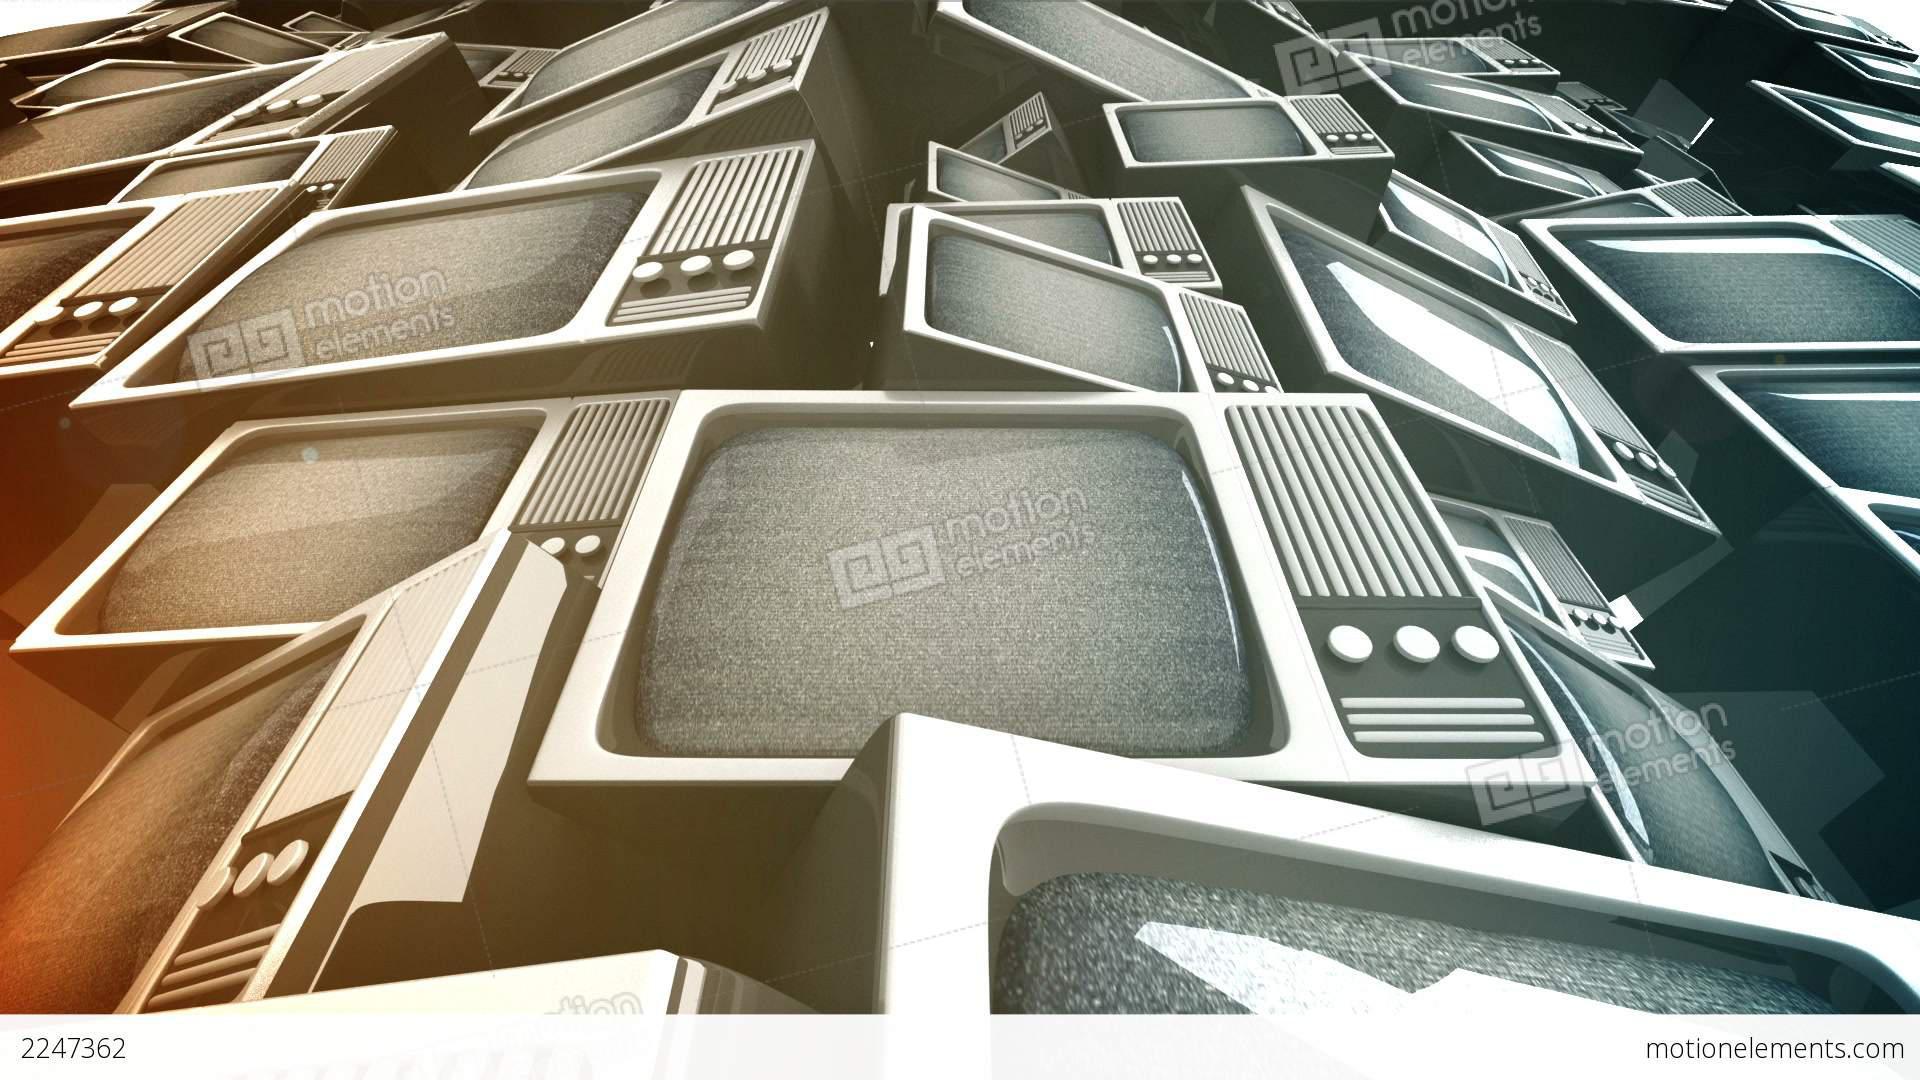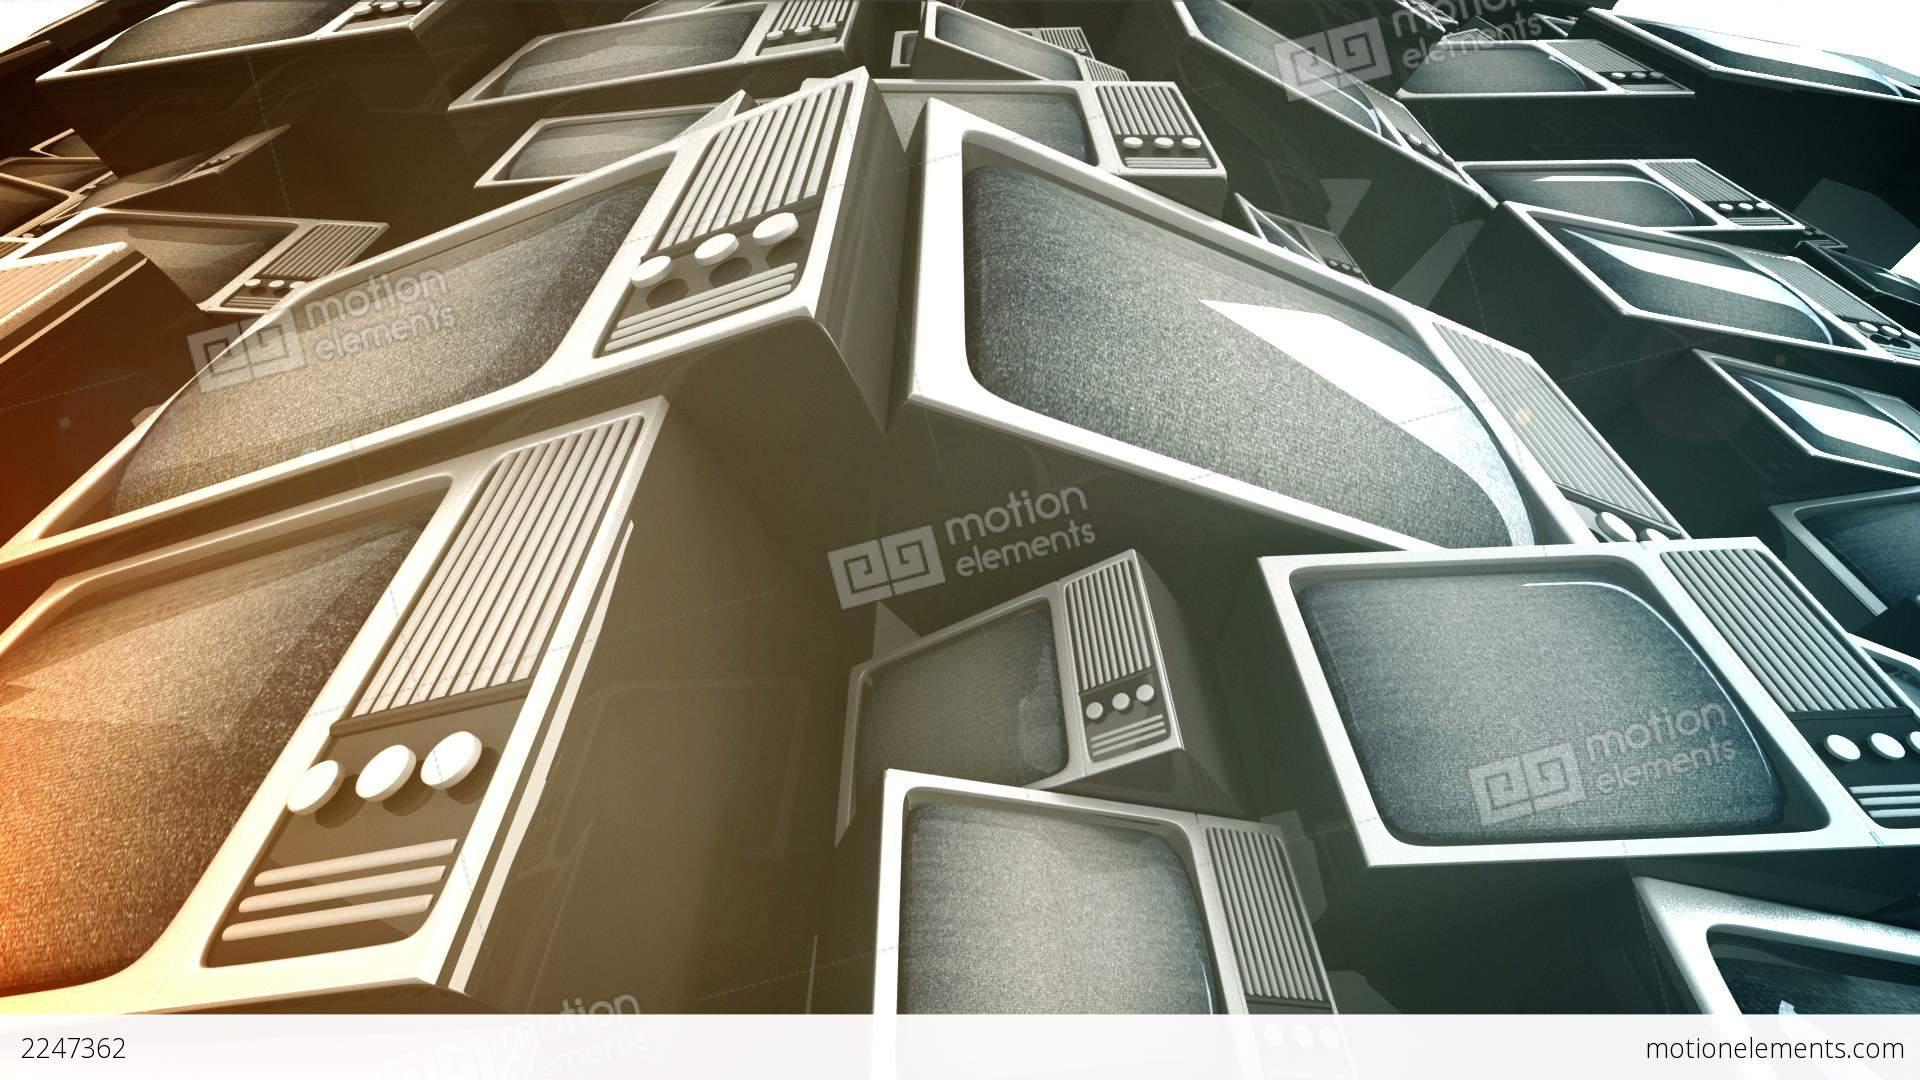The first image is the image on the left, the second image is the image on the right. For the images shown, is this caption "At least one image shows an upward view of 'endless' stacked televisions that feature three round white knobs in a horizontal row right of the screen." true? Answer yes or no. Yes. The first image is the image on the left, the second image is the image on the right. Examine the images to the left and right. Is the description "All the televisions are off." accurate? Answer yes or no. No. 